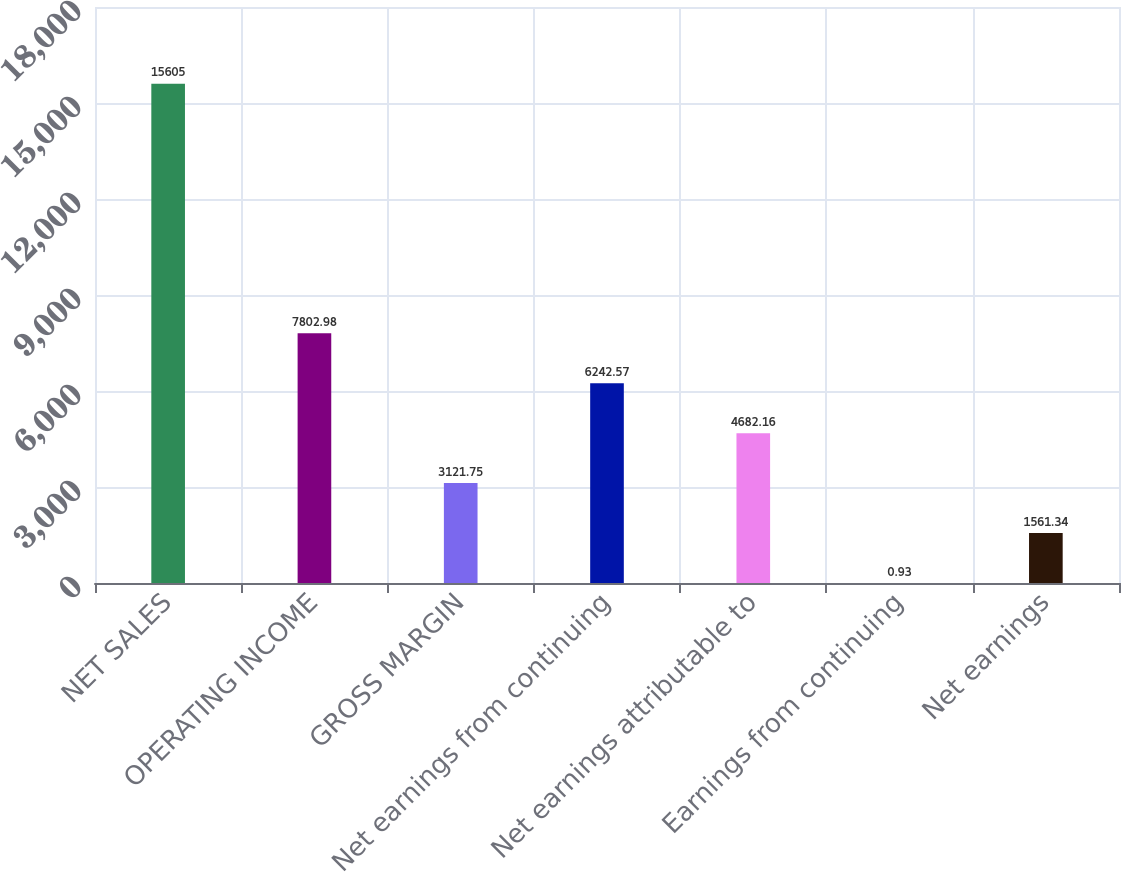Convert chart. <chart><loc_0><loc_0><loc_500><loc_500><bar_chart><fcel>NET SALES<fcel>OPERATING INCOME<fcel>GROSS MARGIN<fcel>Net earnings from continuing<fcel>Net earnings attributable to<fcel>Earnings from continuing<fcel>Net earnings<nl><fcel>15605<fcel>7802.98<fcel>3121.75<fcel>6242.57<fcel>4682.16<fcel>0.93<fcel>1561.34<nl></chart> 